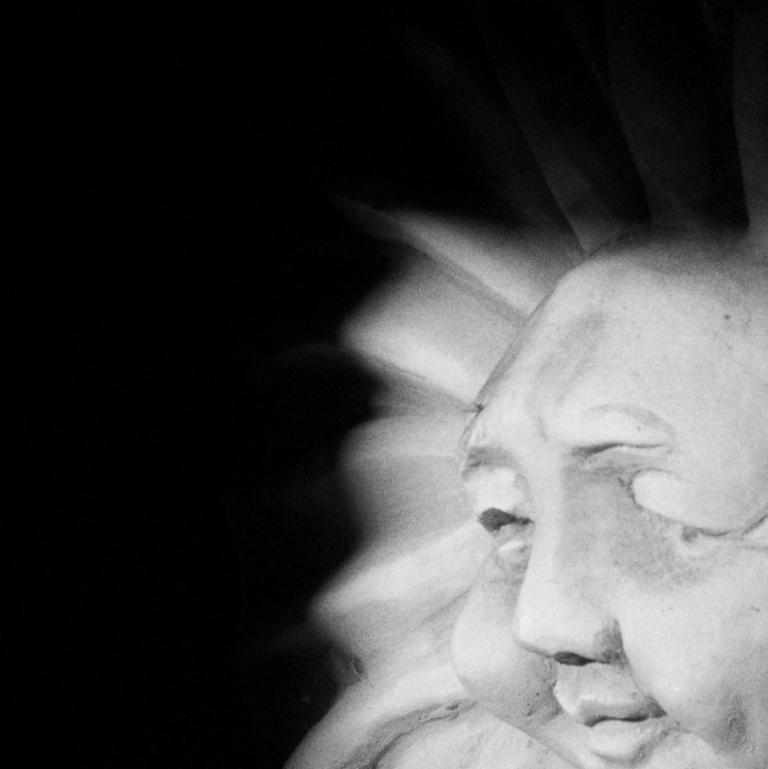Can you describe this image briefly? It is a black and white image. On the right side there is a statue in the shape of a human. 